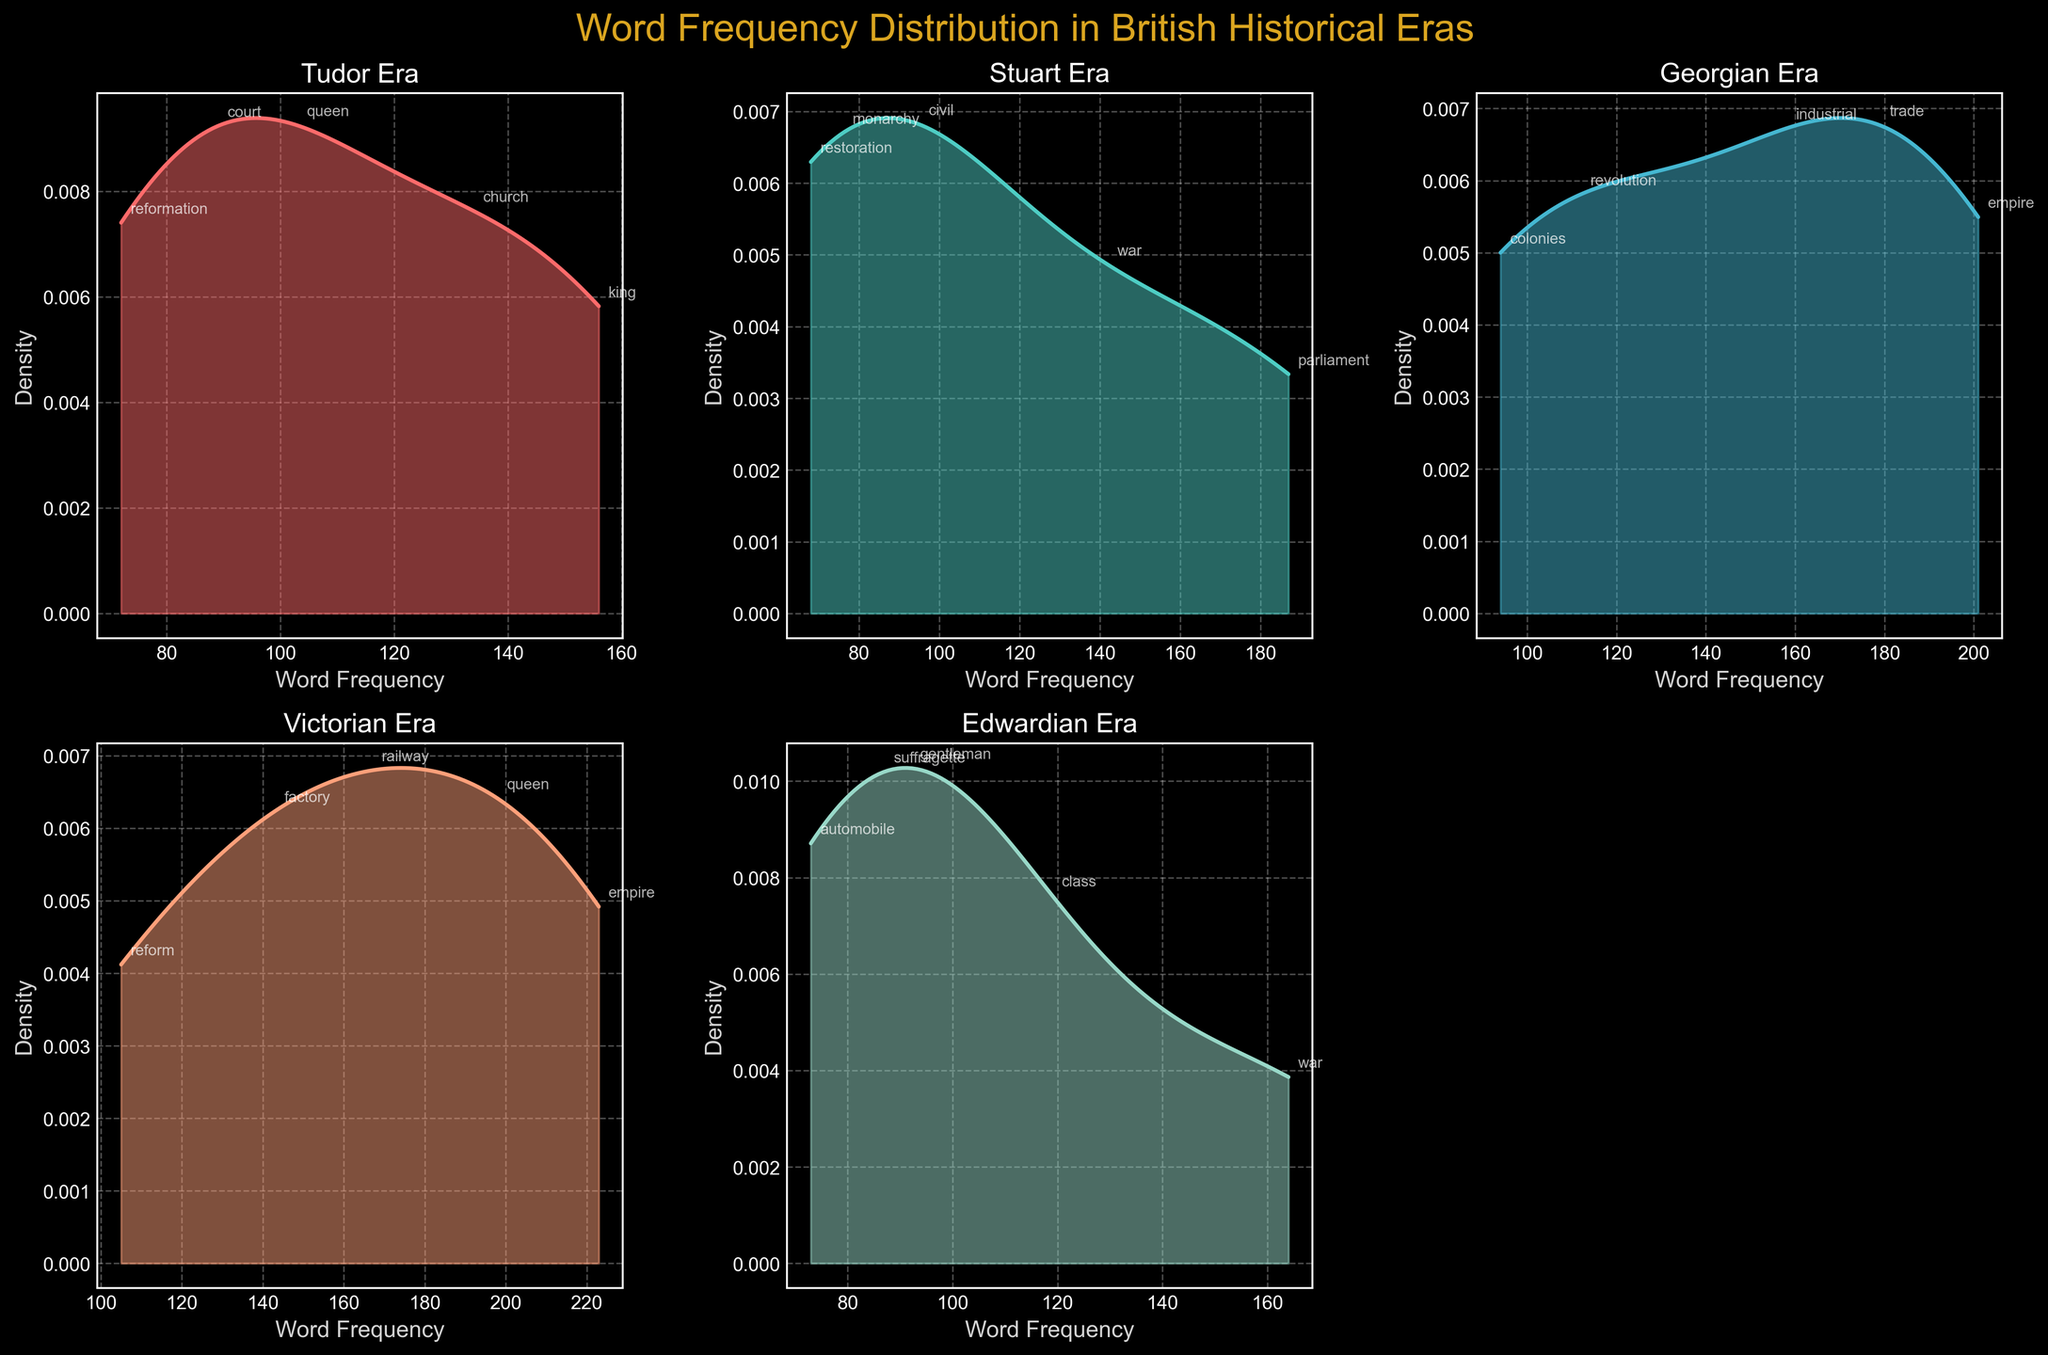What is the title of the figure? The title of the figure is displayed at the top and reads "Word Frequency Distribution in British Historical Eras".
Answer: Word Frequency Distribution in British Historical Eras Which era shows the highest peak density for the word "empire"? To find the highest peak density for the word "empire", look across all subplots and check where "empire" is located. The peak occurs in the Victorian era.
Answer: Victorian era What color is used for the density plot of the Stuart era? The color used for the Stuart era density plot is the second color in the sequence of density plot colors, which is a turquoise shade.
Answer: Turquoise Which era has the word with the highest frequency, and what is that frequency? To determine which era has the highest word frequency, check the annotations in all plots. The highest frequency word is "empire" with a frequency of 223 in the Victorian era.
Answer: Victorian era, 223 How does the frequency distribution of the Tudor era compare to the Georgian era? Examining both density plots, the Tudor era shows a more even spread across frequencies, while the Georgian era has sharper peaks indicating more variance in word frequencies.
Answer: Tudor: even spread, Georgian: sharper peaks Which era has the most similar frequency distribution to the Tudor era? By comparing the shape of the density curves, the Edwardian era has a density distribution most similar to the Tudor era, both with relatively even distribution curves.
Answer: Edwardian era What is the lowest frequency in the Edwardian era, and which word does it pertain to? The lowest frequency in the Edwardian era, according to the annotated points, is for the word "automobile" with a frequency of 73.
Answer: 73, automobile What can be inferred about the relative importance of "parliament" versus "monarchy" in the Stuart era? "Parliament" has a much higher frequency (187) compared to "monarchy" (76), indicating a larger emphasis or more frequent mention of "parliament" in Stuart-era documents.
Answer: "Parliament" is more discussed than "monarchy" Which era has no dedicated subplot in the figure and why? The bottom right subplot does not pertain to any era and is simply left blank. This might be due to the fact that there are five eras and the subplot arrangement is a 2x3 grid, leaving one space empty.
Answer: None specified, blank space How does the frequency of the word "queen" differ between the Victorian and Tudor eras? In the Tudor era, the frequency of "queen" is 103, whereas in the Victorian era, it is 198, indicating a higher frequency in the Victorian books.
Answer: Higher in the Victorian era (198 compared to 103) 